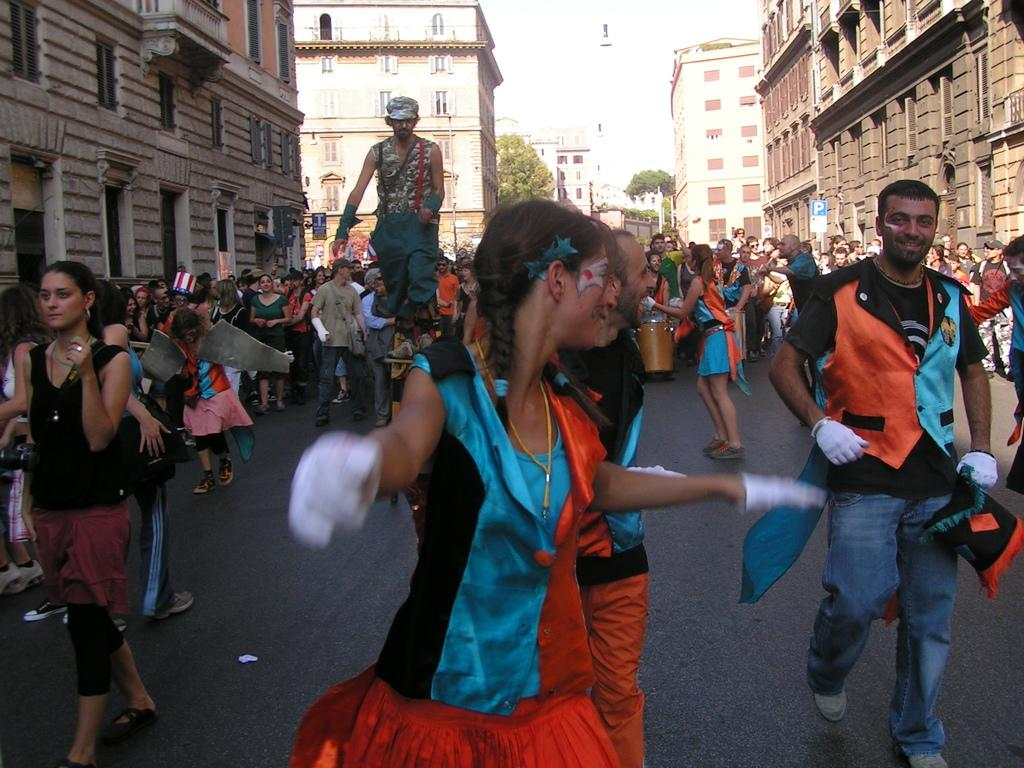What is happening with the people in the image? The people in the image are walking and standing. What are the people holding in their hands? The people are holding something in their hands. What can be seen in the background of the image? There are trees and buildings in the background of the image. What type of instrument is the user playing in the image? There is no instrument present in the image; the people are walking and standing, and holding something in their hands. How many chairs are visible in the image? There are no chairs visible in the image. 